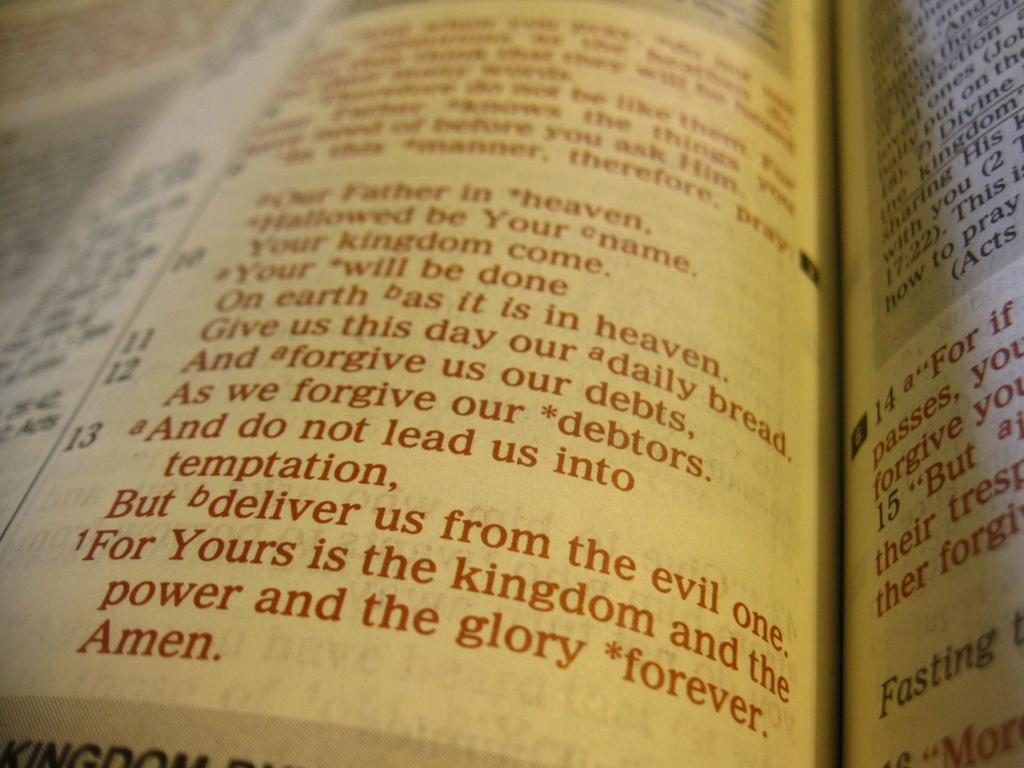Provide a one-sentence caption for the provided image. A white page with red letters with the last line that reads, "Amen.". 